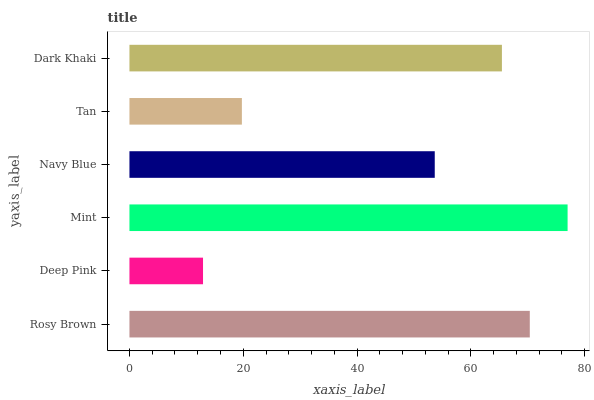Is Deep Pink the minimum?
Answer yes or no. Yes. Is Mint the maximum?
Answer yes or no. Yes. Is Mint the minimum?
Answer yes or no. No. Is Deep Pink the maximum?
Answer yes or no. No. Is Mint greater than Deep Pink?
Answer yes or no. Yes. Is Deep Pink less than Mint?
Answer yes or no. Yes. Is Deep Pink greater than Mint?
Answer yes or no. No. Is Mint less than Deep Pink?
Answer yes or no. No. Is Dark Khaki the high median?
Answer yes or no. Yes. Is Navy Blue the low median?
Answer yes or no. Yes. Is Deep Pink the high median?
Answer yes or no. No. Is Dark Khaki the low median?
Answer yes or no. No. 